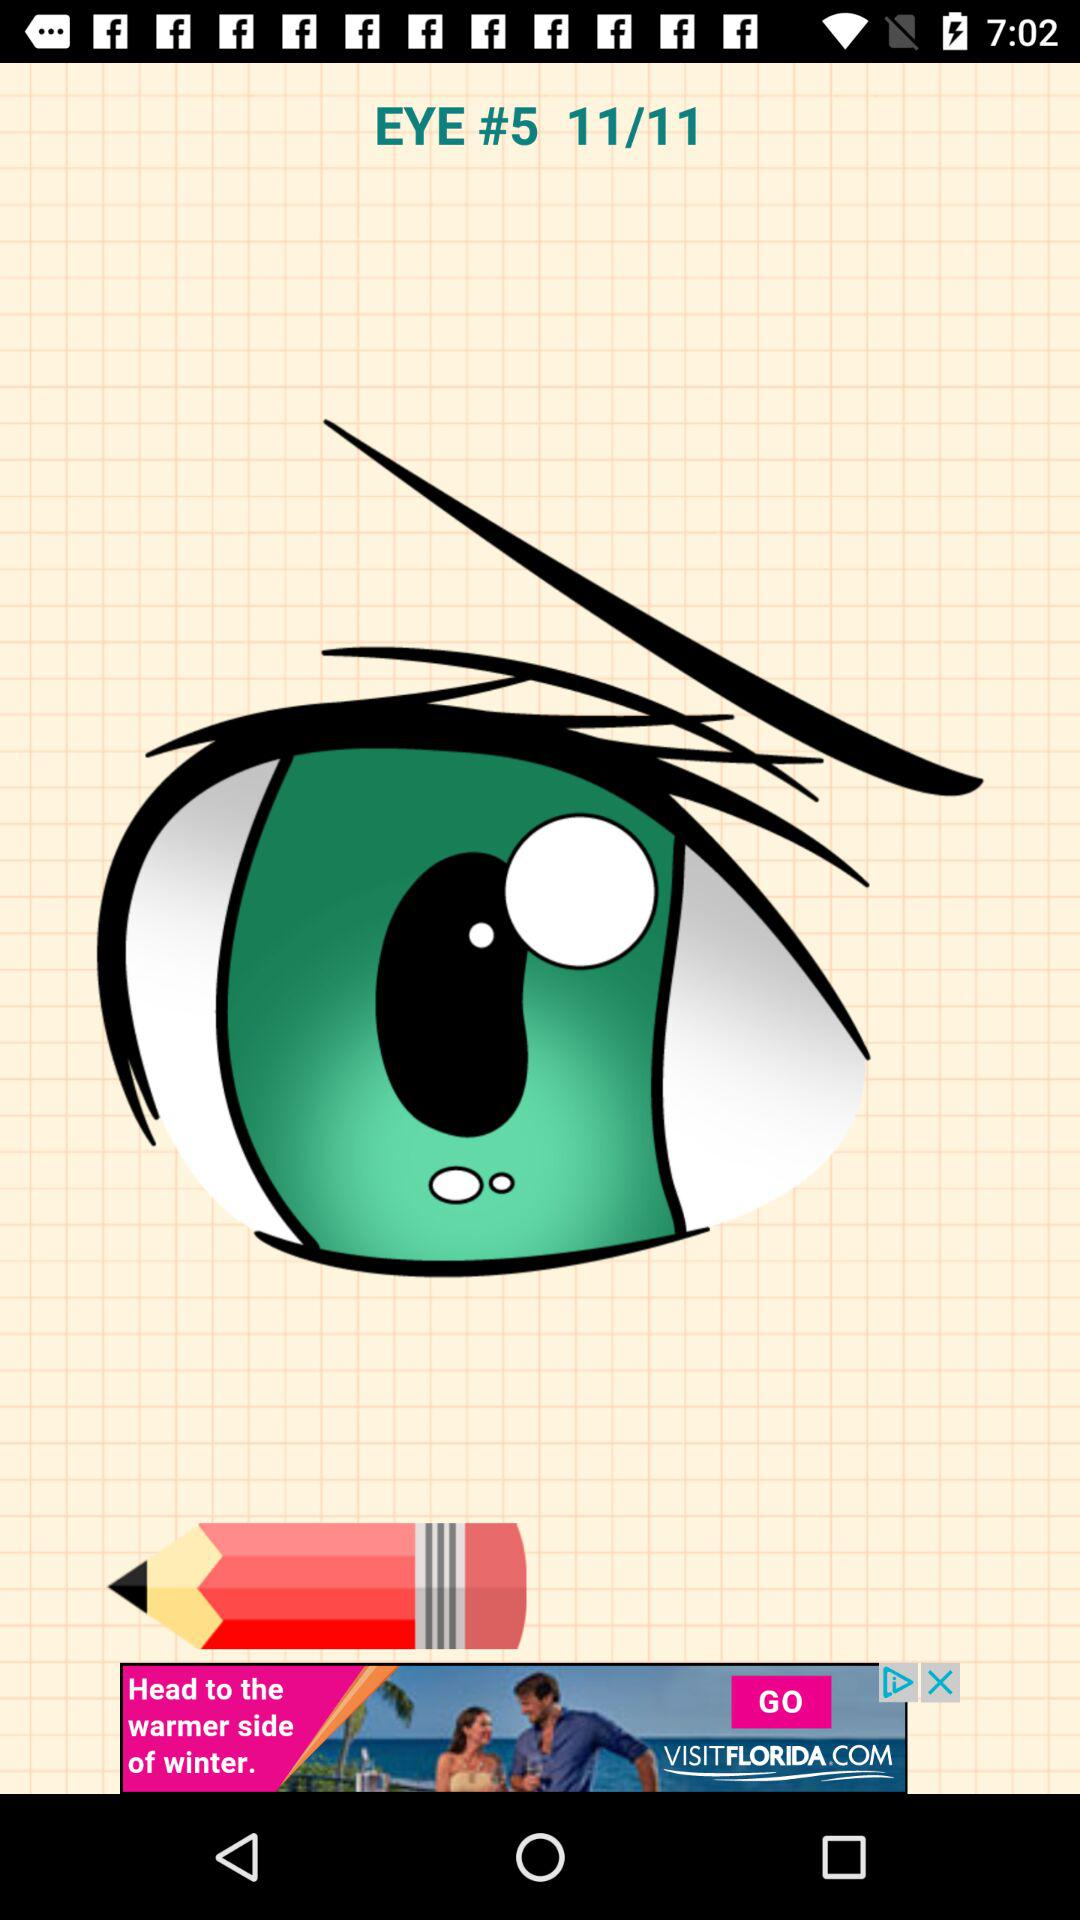How many images in total are there? There are 11 images. 